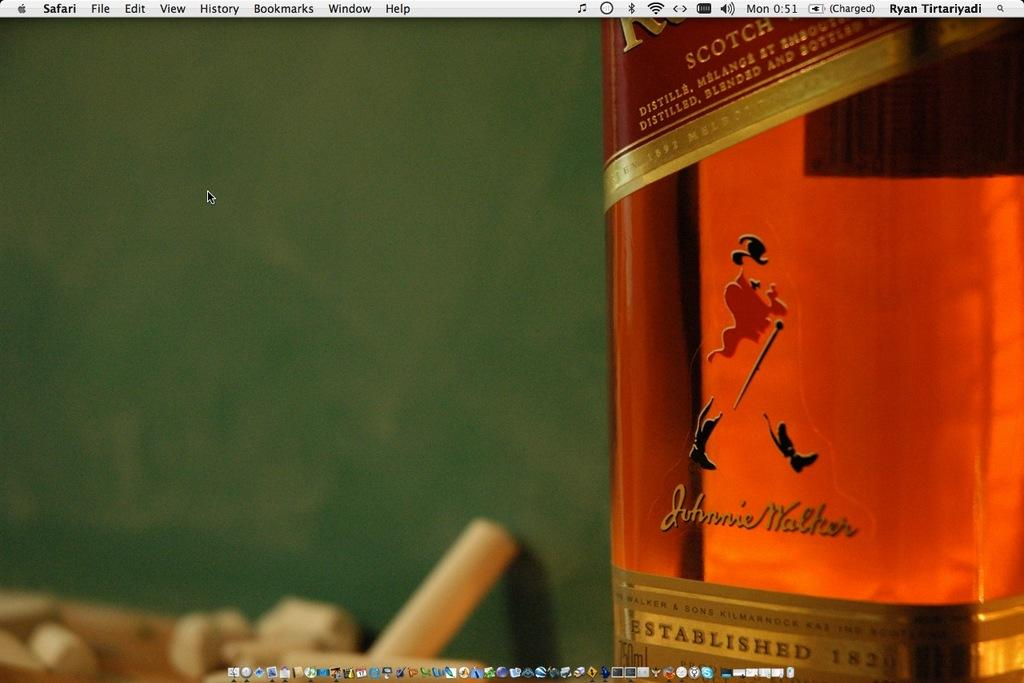Provide a one-sentence caption for the provided image. A bottle of Johnny Walker is sitting on the desktop screen of a computer. 